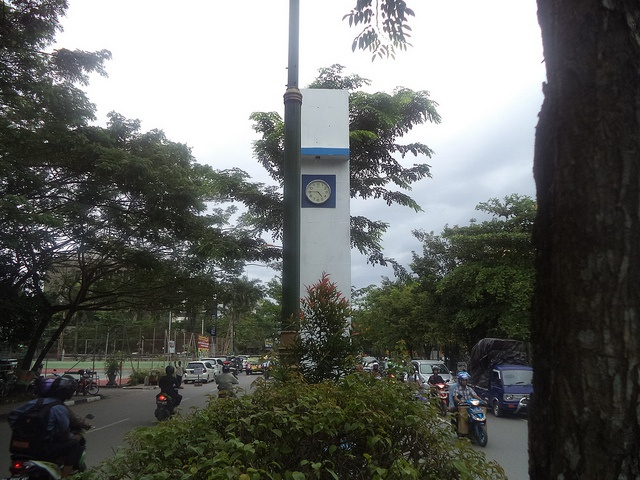Describe the objects in this image and their specific colors. I can see people in gray, black, and darkblue tones, truck in gray and black tones, backpack in gray, black, and darkblue tones, motorcycle in gray, black, and darkgreen tones, and car in gray, darkgray, black, and darkgreen tones in this image. 